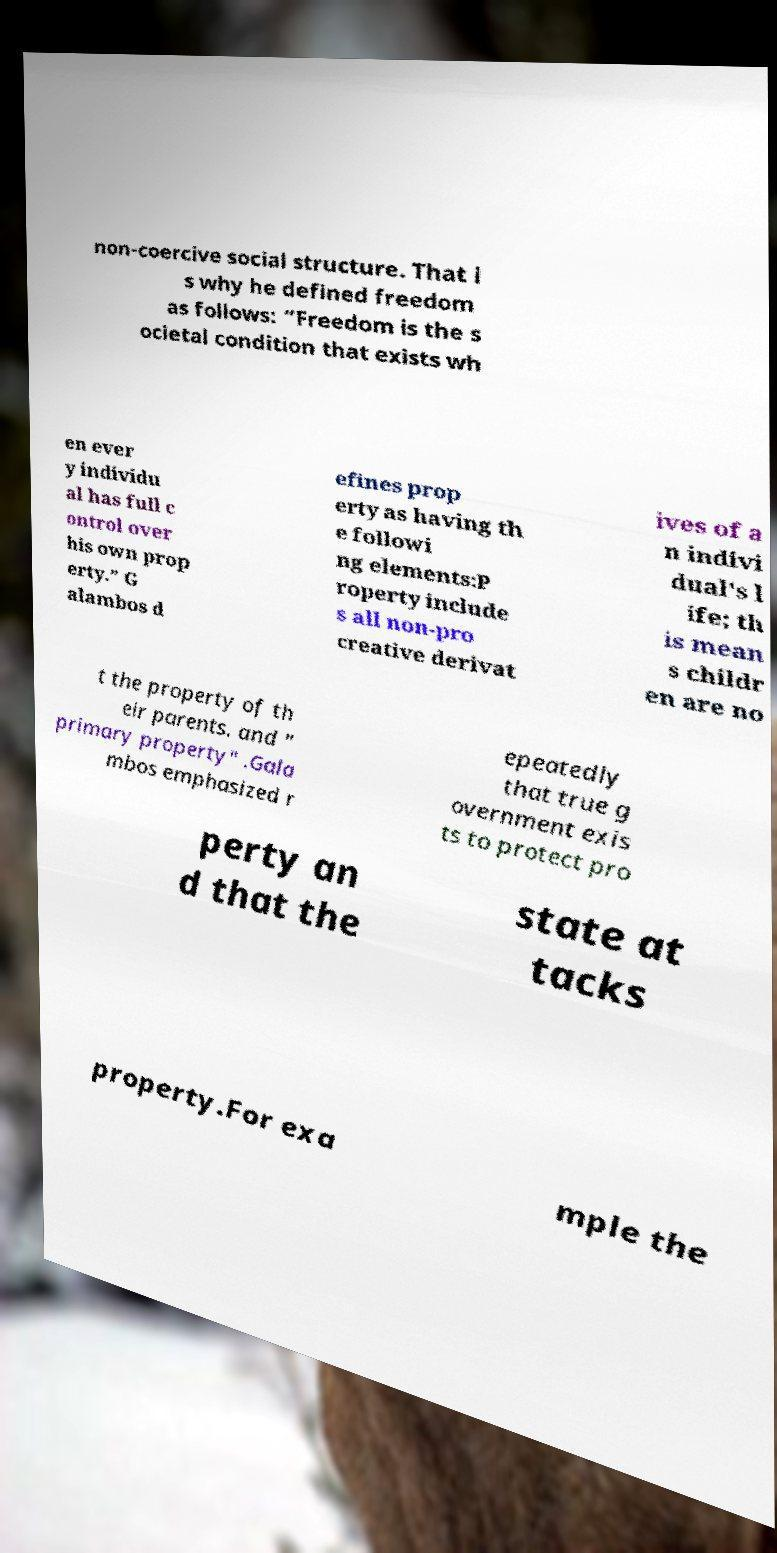Could you extract and type out the text from this image? non-coercive social structure. That i s why he defined freedom as follows: “Freedom is the s ocietal condition that exists wh en ever y individu al has full c ontrol over his own prop erty.” G alambos d efines prop erty as having th e followi ng elements:P roperty include s all non-pro creative derivat ives of a n indivi dual's l ife; th is mean s childr en are no t the property of th eir parents. and " primary property" .Gala mbos emphasized r epeatedly that true g overnment exis ts to protect pro perty an d that the state at tacks property.For exa mple the 